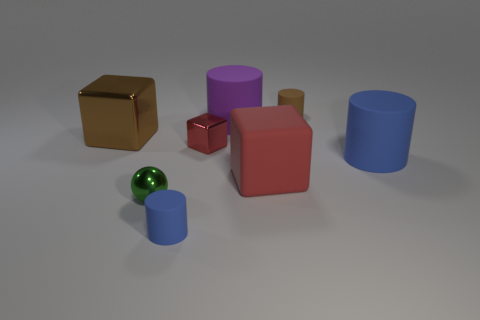What number of big objects are either shiny cubes or yellow matte cubes?
Your answer should be very brief. 1. There is a blue rubber object that is right of the tiny metallic cube that is to the left of the small rubber thing that is behind the tiny red metal cube; what is its size?
Ensure brevity in your answer.  Large. How many brown matte cylinders are the same size as the red shiny thing?
Keep it short and to the point. 1. How many things are either big brown matte objects or red blocks to the left of the matte block?
Give a very brief answer. 1. There is a green object; what shape is it?
Keep it short and to the point. Sphere. Is the matte block the same color as the metallic ball?
Keep it short and to the point. No. Are there an equal number of brown objects and tiny blue objects?
Give a very brief answer. No. There is a rubber cube that is the same size as the brown shiny cube; what is its color?
Ensure brevity in your answer.  Red. What number of green things are tiny objects or spheres?
Provide a succinct answer. 1. Are there more large gray shiny cubes than tiny blue matte cylinders?
Offer a very short reply. No. 